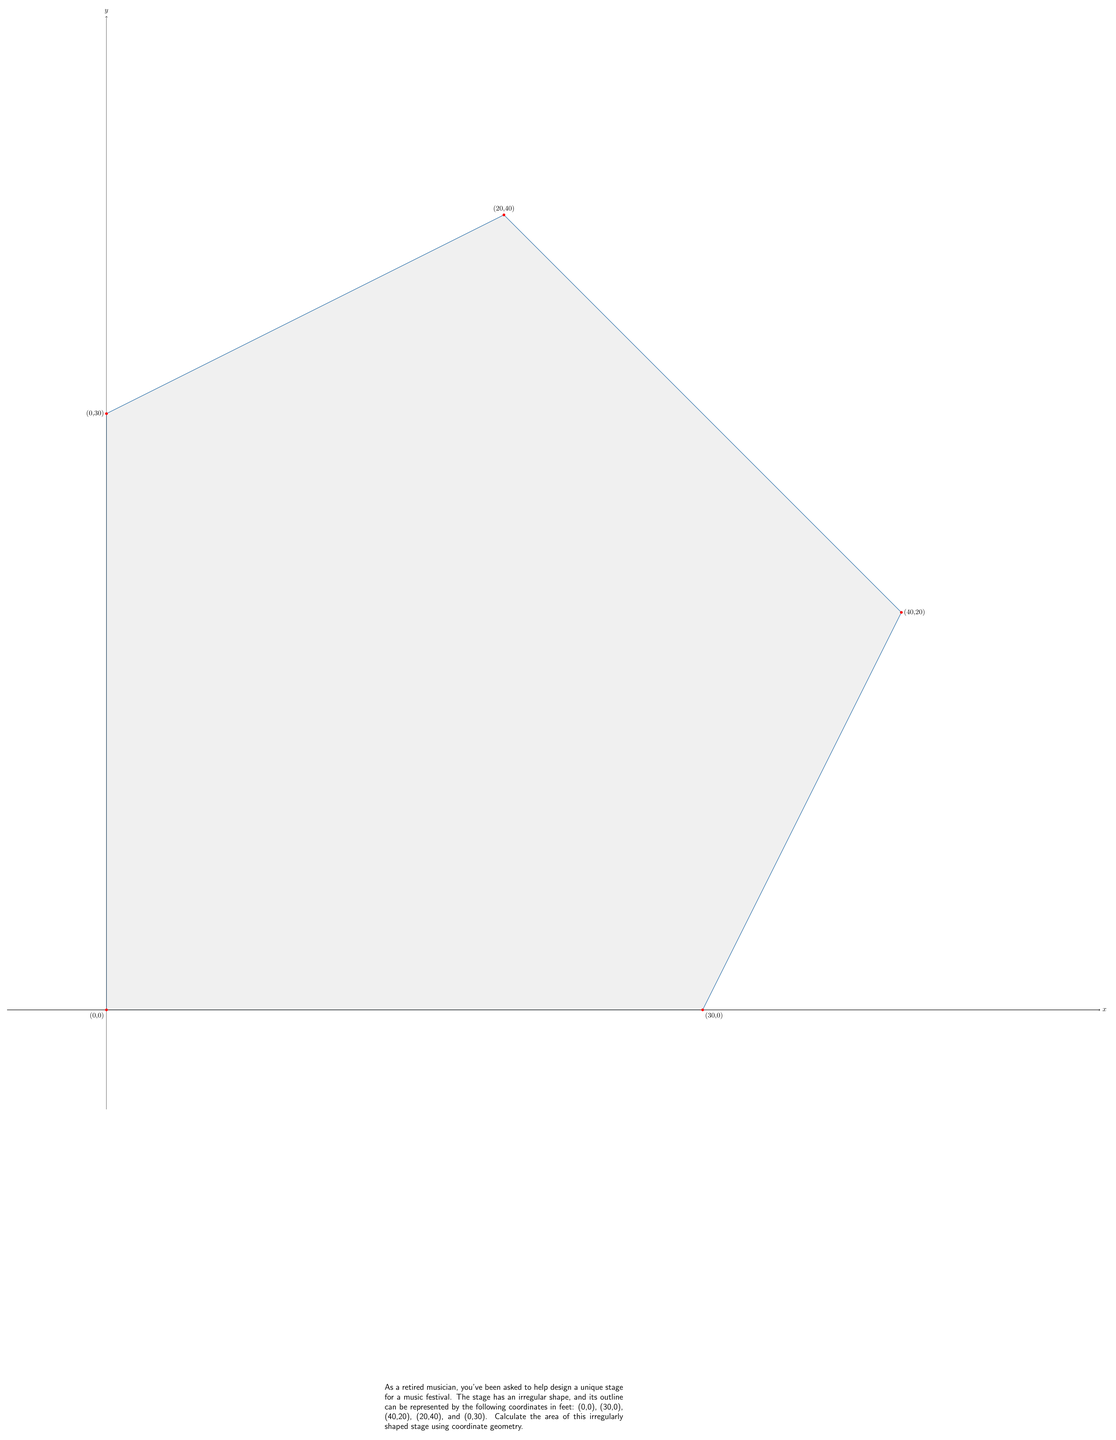Could you help me with this problem? To find the area of this irregular stage, we can use the Shoelace formula (also known as the surveyor's formula). This method calculates the area of a polygon given the coordinates of its vertices.

The formula is:

$$ A = \frac{1}{2}|\sum_{i=1}^{n-1} (x_iy_{i+1} - x_{i+1}y_i) + (x_ny_1 - x_1y_n)| $$

Where $(x_i, y_i)$ are the coordinates of the $i$-th vertex.

Let's apply this formula to our stage:

1) List the coordinates in order:
   $(0,0)$, $(30,0)$, $(40,20)$, $(20,40)$, $(0,30)$

2) Calculate each term in the sum:
   $0 \cdot 0 - 30 \cdot 0 = 0$
   $30 \cdot 20 - 40 \cdot 0 = 600$
   $40 \cdot 40 - 20 \cdot 20 = 1200$
   $20 \cdot 30 - 0 \cdot 40 = 600$
   $0 \cdot 0 - 0 \cdot 30 = 0$

3) Sum these terms:
   $0 + 600 + 1200 + 600 + 0 = 2400$

4) Take the absolute value and divide by 2:
   $\frac{1}{2}|2400| = 1200$

Therefore, the area of the stage is 1200 square feet.
Answer: 1200 sq ft 